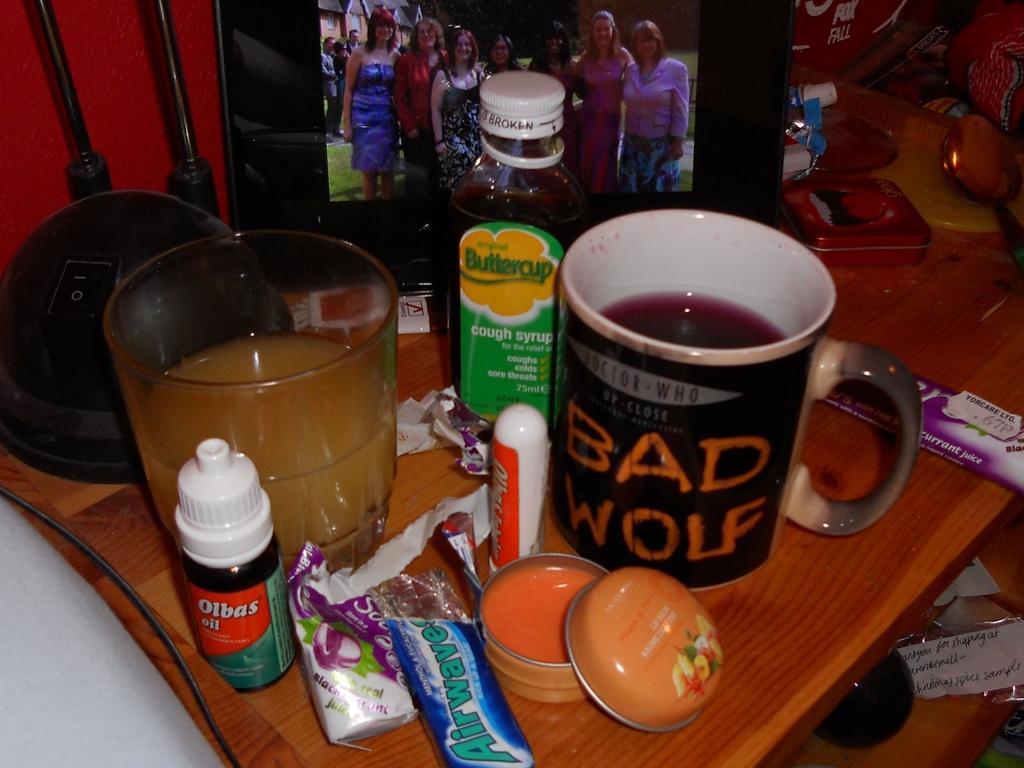What is written on the mug?
Give a very brief answer. Bad wolf. What is the gum name?
Make the answer very short. Airwave. 